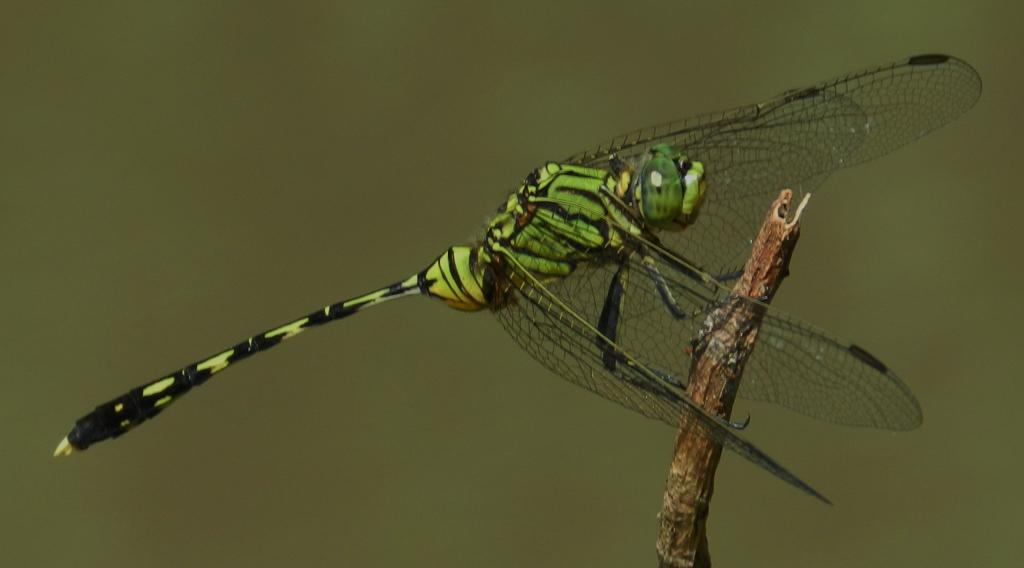What is present in the image? There is an insect in the image. Where is the insect located? The insect is on a stem. What colors can be seen on the insect? The insect has green and black colors. What is the color of the background in the image? The background of the image is green. What type of current can be seen flowing through the alley in the image? There is no current or alley present in the image; it features an insect on a stem with a green background. 